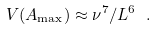<formula> <loc_0><loc_0><loc_500><loc_500>V ( A _ { \max } ) \approx \nu ^ { 7 } / L ^ { 6 } \ .</formula> 